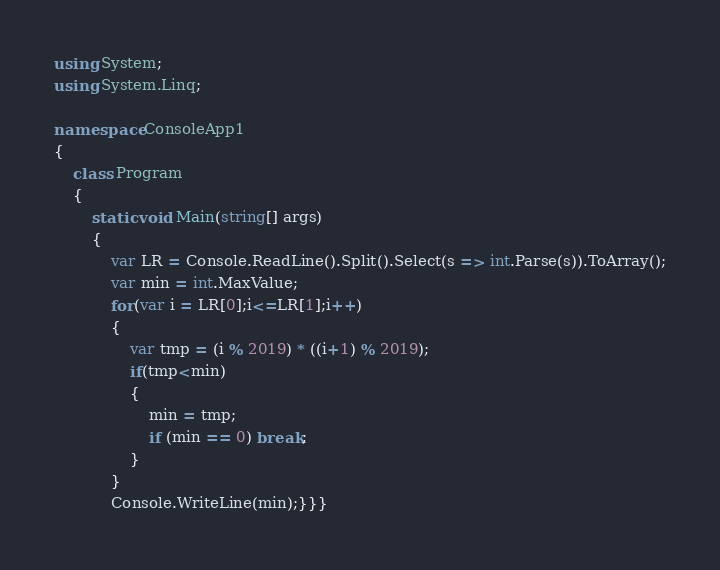Convert code to text. <code><loc_0><loc_0><loc_500><loc_500><_C#_>using System;
using System.Linq;

namespace ConsoleApp1
{
    class Program
    {
        static void Main(string[] args)
        {
            var LR = Console.ReadLine().Split().Select(s => int.Parse(s)).ToArray();
            var min = int.MaxValue;
            for(var i = LR[0];i<=LR[1];i++)
            {
                var tmp = (i % 2019) * ((i+1) % 2019);
                if(tmp<min)
                {
                    min = tmp;
                    if (min == 0) break;
                }
            }
            Console.WriteLine(min);}}}</code> 